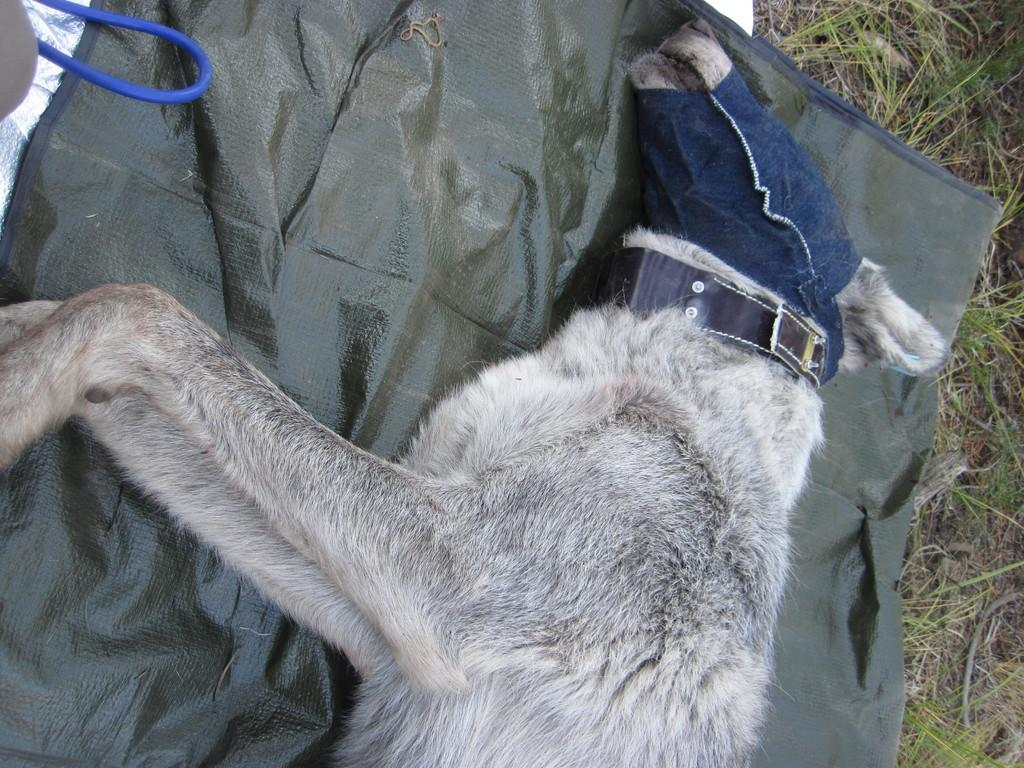What type of animal is in the image? There is a dog in the image. What colors can be seen on the dog? The dog is white and black in color. What is the dog lying on? The dog is lying on a green colored sheet. What type of vegetation is visible on the ground in the image? There is grass on the ground in the image. What color is the wire in the image? There is a blue colored wire in the image. What decision does the dog make in the image? The image does not depict the dog making any decisions; it simply shows the dog lying on a green colored sheet. 